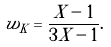<formula> <loc_0><loc_0><loc_500><loc_500>w _ { K } = \frac { X - 1 } { 3 X - 1 } .</formula> 